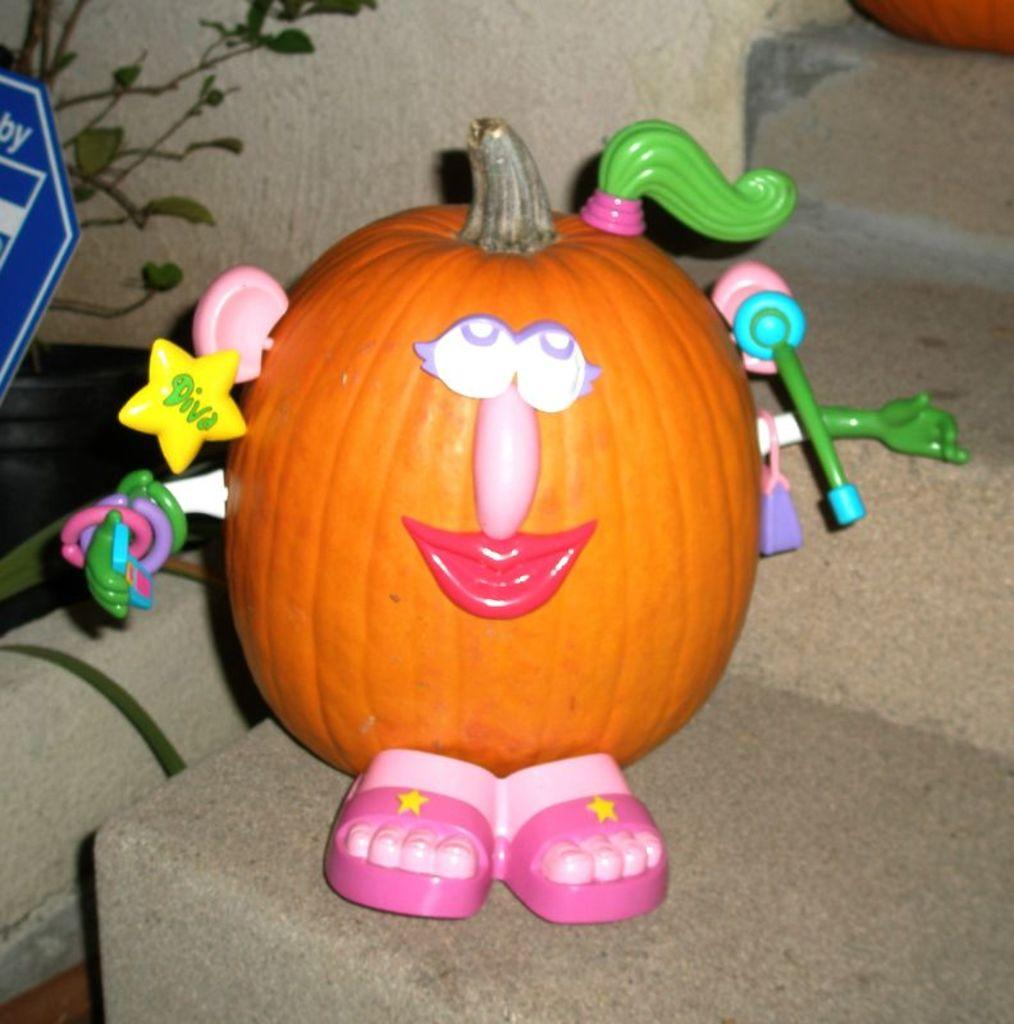What is placed on the stairs in the image? There is a pumpkin on the stairs. What is on top of the pumpkin on the stairs? There are toys on the pumpkin. What can be seen on the left side of the image? There is a plant and a blue object on the left side of the image. Are there any other pumpkins visible in the image? Yes, there is another pumpkin on top of the stairs. What type of liquid is dripping from the branch in the image? There is no branch or liquid present in the image. What is causing the pain in the image? There is no indication of pain or any related subject in the image. 